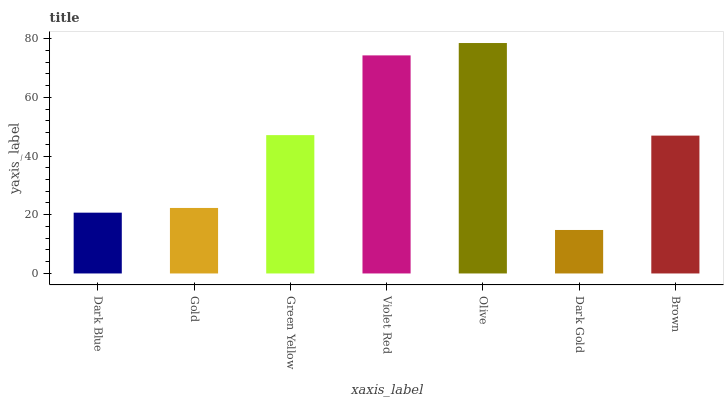Is Dark Gold the minimum?
Answer yes or no. Yes. Is Olive the maximum?
Answer yes or no. Yes. Is Gold the minimum?
Answer yes or no. No. Is Gold the maximum?
Answer yes or no. No. Is Gold greater than Dark Blue?
Answer yes or no. Yes. Is Dark Blue less than Gold?
Answer yes or no. Yes. Is Dark Blue greater than Gold?
Answer yes or no. No. Is Gold less than Dark Blue?
Answer yes or no. No. Is Brown the high median?
Answer yes or no. Yes. Is Brown the low median?
Answer yes or no. Yes. Is Dark Gold the high median?
Answer yes or no. No. Is Dark Gold the low median?
Answer yes or no. No. 